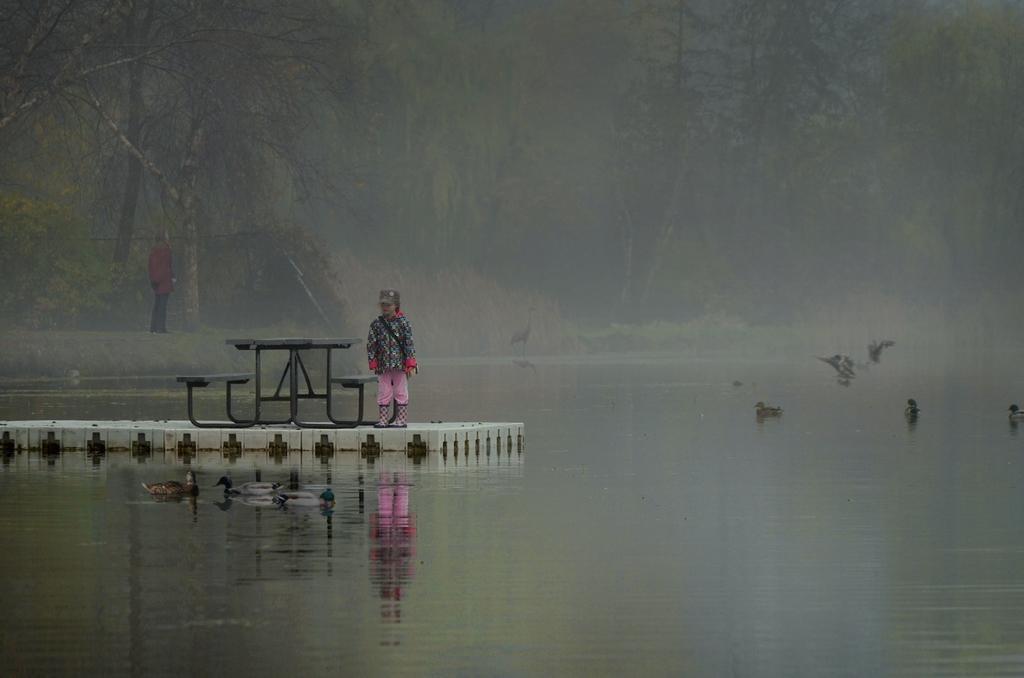Please provide a concise description of this image. In this image in the front there is water. In the center there is a person standing and there is an object which is black in colour. In the background there are birds and there is a person and there are trees. 